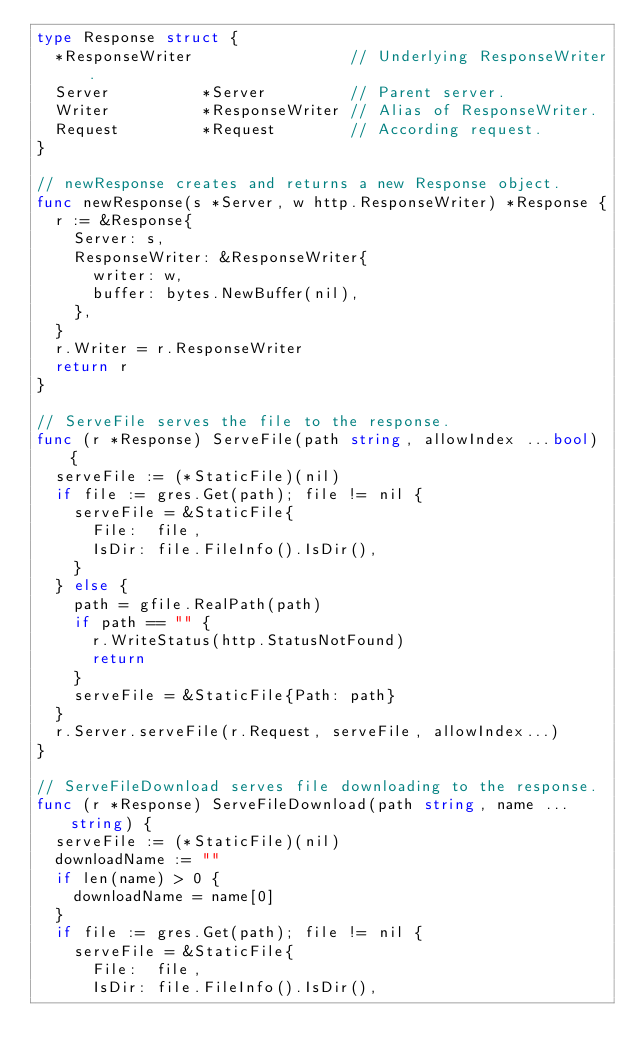Convert code to text. <code><loc_0><loc_0><loc_500><loc_500><_Go_>type Response struct {
	*ResponseWriter                 // Underlying ResponseWriter.
	Server          *Server         // Parent server.
	Writer          *ResponseWriter // Alias of ResponseWriter.
	Request         *Request        // According request.
}

// newResponse creates and returns a new Response object.
func newResponse(s *Server, w http.ResponseWriter) *Response {
	r := &Response{
		Server: s,
		ResponseWriter: &ResponseWriter{
			writer: w,
			buffer: bytes.NewBuffer(nil),
		},
	}
	r.Writer = r.ResponseWriter
	return r
}

// ServeFile serves the file to the response.
func (r *Response) ServeFile(path string, allowIndex ...bool) {
	serveFile := (*StaticFile)(nil)
	if file := gres.Get(path); file != nil {
		serveFile = &StaticFile{
			File:  file,
			IsDir: file.FileInfo().IsDir(),
		}
	} else {
		path = gfile.RealPath(path)
		if path == "" {
			r.WriteStatus(http.StatusNotFound)
			return
		}
		serveFile = &StaticFile{Path: path}
	}
	r.Server.serveFile(r.Request, serveFile, allowIndex...)
}

// ServeFileDownload serves file downloading to the response.
func (r *Response) ServeFileDownload(path string, name ...string) {
	serveFile := (*StaticFile)(nil)
	downloadName := ""
	if len(name) > 0 {
		downloadName = name[0]
	}
	if file := gres.Get(path); file != nil {
		serveFile = &StaticFile{
			File:  file,
			IsDir: file.FileInfo().IsDir(),</code> 